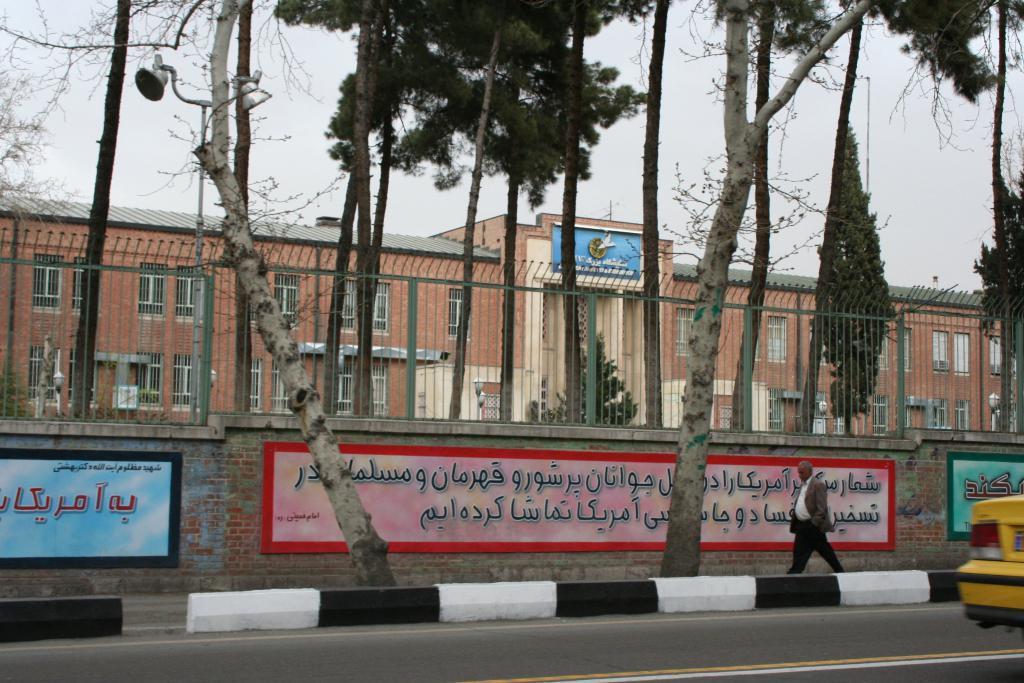In one or two sentences, can you explain what this image depicts? In this image I can see the road, a yellow colored vehicle on the road, a person standing on the road, few trees, the wall to which I can see few paintings and the railing. In the background I can see few trees, a building and the sky. 